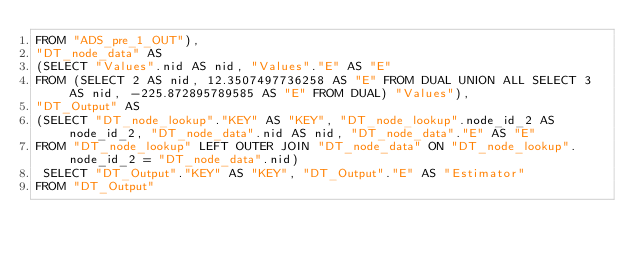Convert code to text. <code><loc_0><loc_0><loc_500><loc_500><_SQL_>FROM "ADS_pre_1_OUT"), 
"DT_node_data" AS 
(SELECT "Values".nid AS nid, "Values"."E" AS "E" 
FROM (SELECT 2 AS nid, 12.3507497736258 AS "E" FROM DUAL UNION ALL SELECT 3 AS nid, -225.872895789585 AS "E" FROM DUAL) "Values"), 
"DT_Output" AS 
(SELECT "DT_node_lookup"."KEY" AS "KEY", "DT_node_lookup".node_id_2 AS node_id_2, "DT_node_data".nid AS nid, "DT_node_data"."E" AS "E" 
FROM "DT_node_lookup" LEFT OUTER JOIN "DT_node_data" ON "DT_node_lookup".node_id_2 = "DT_node_data".nid)
 SELECT "DT_Output"."KEY" AS "KEY", "DT_Output"."E" AS "Estimator" 
FROM "DT_Output"</code> 